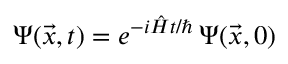<formula> <loc_0><loc_0><loc_500><loc_500>\Psi ( \vec { x } , t ) = e ^ { - i \hat { H } t / } \, \Psi ( \vec { x } , 0 )</formula> 